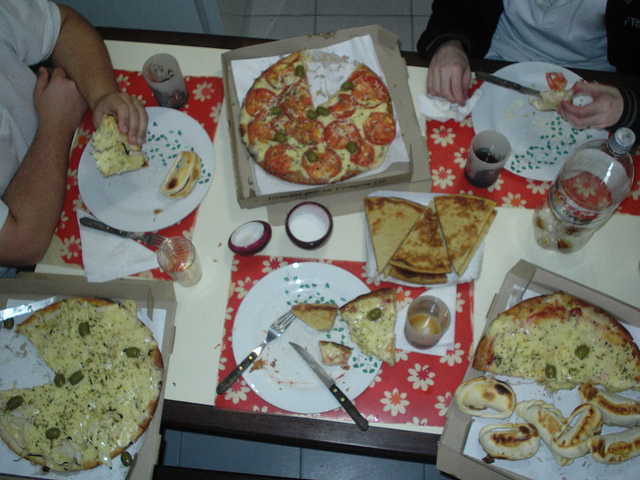<image>Which pizza is pepperoni? I don't know which pizza is pepperoni. It could be the top or front pizza or none of them. Which pizza is pepperoni? I am not sure which pizza is pepperoni. 